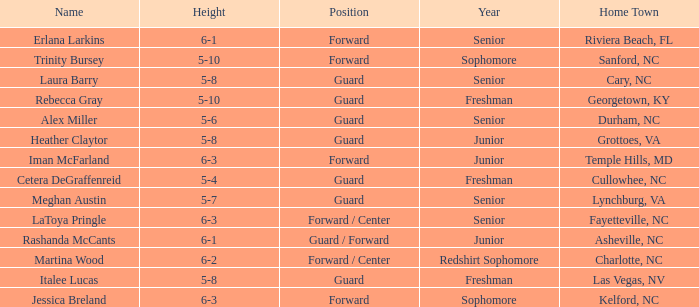In what year of school is the forward Iman McFarland? Junior. 